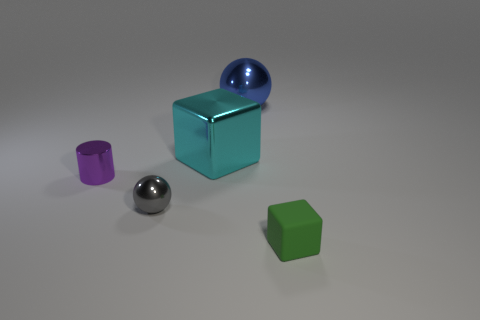Add 5 small cylinders. How many objects exist? 10 Subtract all cylinders. How many objects are left? 4 Add 1 tiny things. How many tiny things are left? 4 Add 4 matte things. How many matte things exist? 5 Subtract 0 gray cylinders. How many objects are left? 5 Subtract all tiny spheres. Subtract all blue objects. How many objects are left? 3 